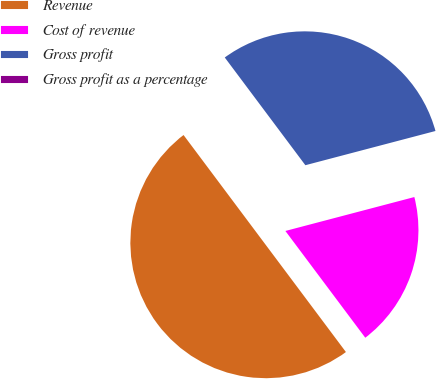Convert chart to OTSL. <chart><loc_0><loc_0><loc_500><loc_500><pie_chart><fcel>Revenue<fcel>Cost of revenue<fcel>Gross profit<fcel>Gross profit as a percentage<nl><fcel>50.0%<fcel>18.87%<fcel>31.13%<fcel>0.0%<nl></chart> 